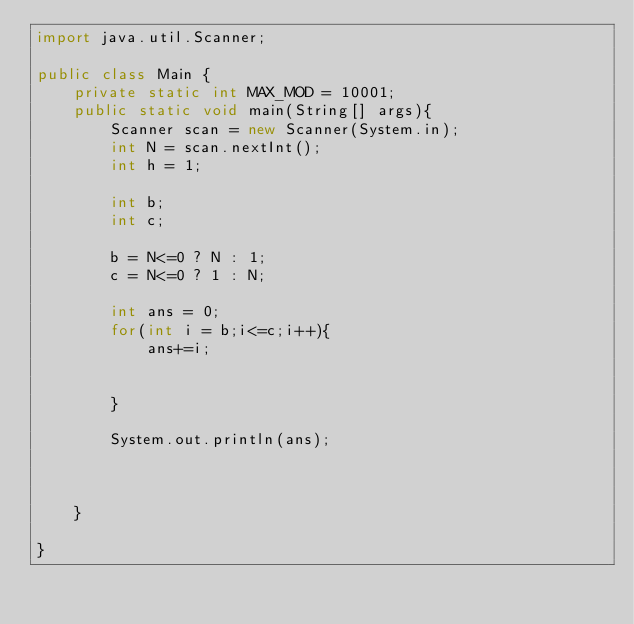<code> <loc_0><loc_0><loc_500><loc_500><_Java_>import java.util.Scanner;

public class Main {
	private static int MAX_MOD = 10001;
	public static void main(String[] args){
		Scanner scan = new Scanner(System.in);
		int N = scan.nextInt();
		int h = 1;
		
		int b;
		int c;
		
		b = N<=0 ? N : 1;
		c = N<=0 ? 1 : N;
		
		int ans = 0;
		for(int i = b;i<=c;i++){
			ans+=i;
			
			
		}
		
		System.out.println(ans);
		
		
		
	}

}

</code> 